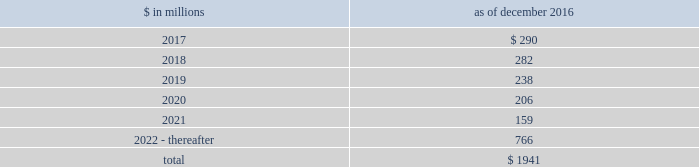The goldman sachs group , inc .
And subsidiaries notes to consolidated financial statements commercial lending .
The firm 2019s commercial lending commitments are extended to investment-grade and non- investment-grade corporate borrowers .
Commitments to investment-grade corporate borrowers are principally used for operating liquidity and general corporate purposes .
The firm also extends lending commitments in connection with contingent acquisition financing and other types of corporate lending as well as commercial real estate financing .
Commitments that are extended for contingent acquisition financing are often intended to be short-term in nature , as borrowers often seek to replace them with other funding sources .
Sumitomo mitsui financial group , inc .
( smfg ) provides the firm with credit loss protection on certain approved loan commitments ( primarily investment-grade commercial lending commitments ) .
The notional amount of such loan commitments was $ 26.88 billion and $ 27.03 billion as of december 2016 and december 2015 , respectively .
The credit loss protection on loan commitments provided by smfg is generally limited to 95% ( 95 % ) of the first loss the firm realizes on such commitments , up to a maximum of approximately $ 950 million .
In addition , subject to the satisfaction of certain conditions , upon the firm 2019s request , smfg will provide protection for 70% ( 70 % ) of additional losses on such commitments , up to a maximum of $ 1.13 billion , of which $ 768 million of protection had been provided as of both december 2016 and december 2015 .
The firm also uses other financial instruments to mitigate credit risks related to certain commitments not covered by smfg .
These instruments primarily include credit default swaps that reference the same or similar underlying instrument or entity , or credit default swaps that reference a market index .
Warehouse financing .
The firm provides financing to clients who warehouse financial assets .
These arrangements are secured by the warehoused assets , primarily consisting of consumer and corporate loans .
Contingent and forward starting resale and securities borrowing agreements/forward starting repurchase and secured lending agreements the firm enters into resale and securities borrowing agreements and repurchase and secured lending agreements that settle at a future date , generally within three business days .
The firm also enters into commitments to provide contingent financing to its clients and counterparties through resale agreements .
The firm 2019s funding of these commitments depends on the satisfaction of all contractual conditions to the resale agreement and these commitments can expire unused .
Letters of credit the firm has commitments under letters of credit issued by various banks which the firm provides to counterparties in lieu of securities or cash to satisfy various collateral and margin deposit requirements .
Investment commitments the firm 2019s investment commitments include commitments to invest in private equity , real estate and other assets directly and through funds that the firm raises and manages .
Investment commitments include $ 2.10 billion and $ 2.86 billion as of december 2016 and december 2015 , respectively , related to commitments to invest in funds managed by the firm .
If these commitments are called , they would be funded at market value on the date of investment .
Leases the firm has contractual obligations under long-term noncancelable lease agreements for office space expiring on various dates through 2069 .
Certain agreements are subject to periodic escalation provisions for increases in real estate taxes and other charges .
The table below presents future minimum rental payments , net of minimum sublease rentals .
$ in millions december 2016 .
Rent charged to operating expense was $ 244 million for 2016 , $ 249 million for 2015 and $ 309 million for 2014 .
Operating leases include office space held in excess of current requirements .
Rent expense relating to space held for growth is included in 201coccupancy . 201d the firm records a liability , based on the fair value of the remaining lease rentals reduced by any potential or existing sublease rentals , for leases where the firm has ceased using the space and management has concluded that the firm will not derive any future economic benefits .
Costs to terminate a lease before the end of its term are recognized and measured at fair value on termination .
During 2016 , the firm incurred exit costs of approximately $ 68 million related to excess office space .
Goldman sachs 2016 form 10-k 169 .
What percentage of future minimum rental payments are due in 2018? 
Computations: (282 / 1941)
Answer: 0.14529. 